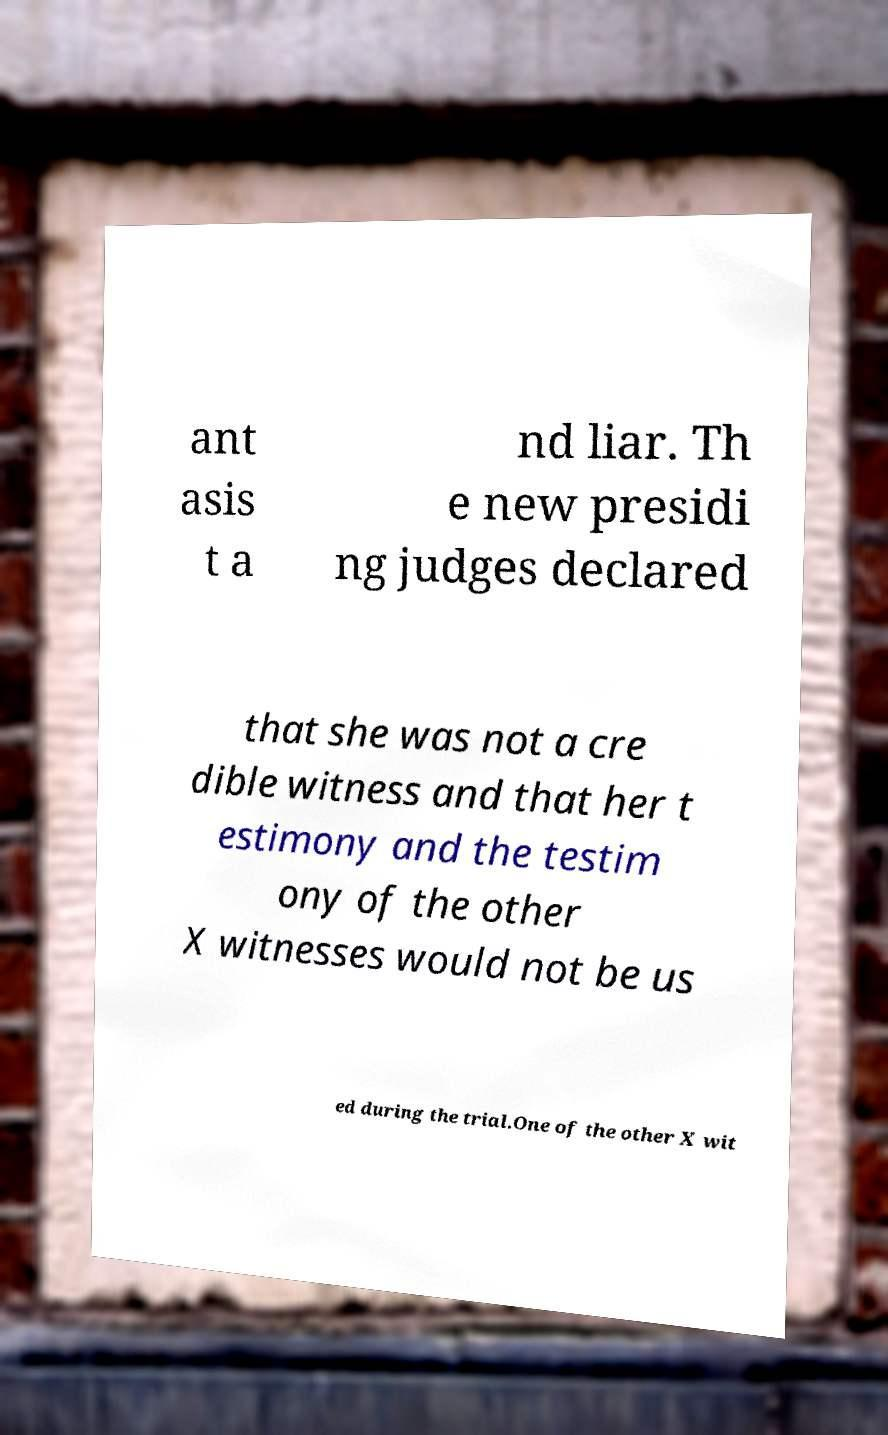Could you extract and type out the text from this image? ant asis t a nd liar. Th e new presidi ng judges declared that she was not a cre dible witness and that her t estimony and the testim ony of the other X witnesses would not be us ed during the trial.One of the other X wit 